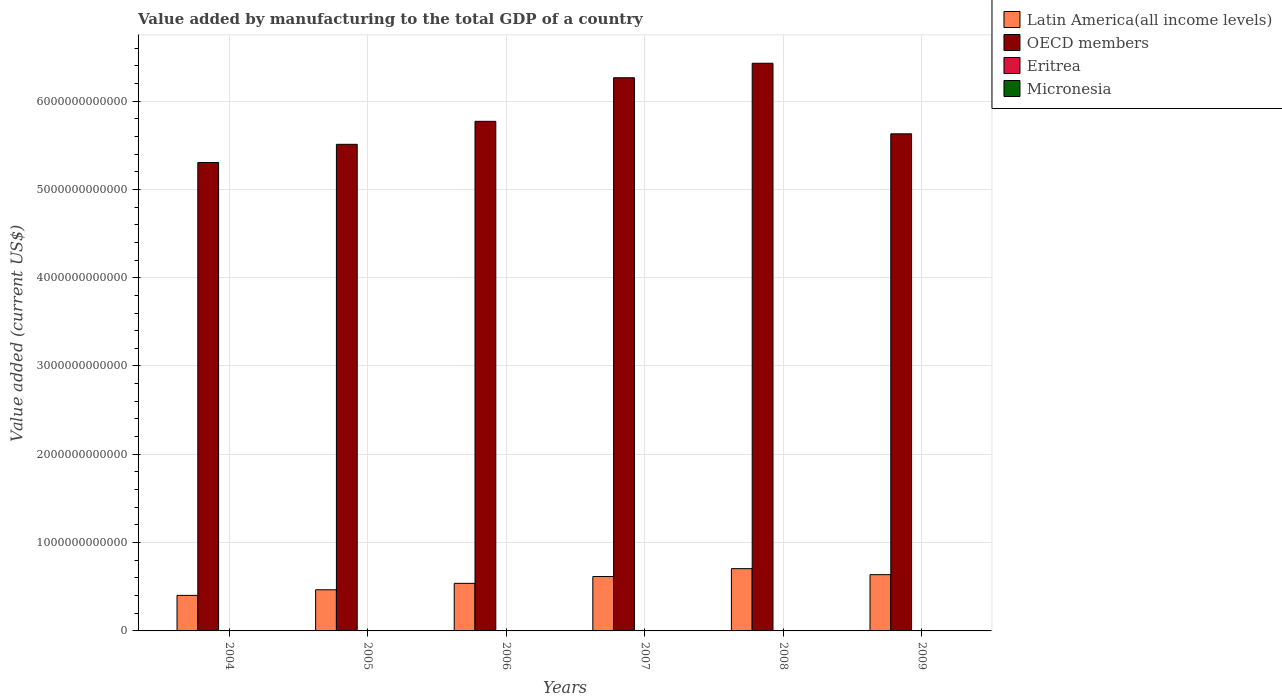Are the number of bars per tick equal to the number of legend labels?
Your response must be concise. Yes. How many bars are there on the 1st tick from the right?
Your answer should be very brief. 4. What is the label of the 6th group of bars from the left?
Offer a very short reply. 2009. What is the value added by manufacturing to the total GDP in Latin America(all income levels) in 2006?
Give a very brief answer. 5.39e+11. Across all years, what is the maximum value added by manufacturing to the total GDP in Eritrea?
Your response must be concise. 1.02e+08. Across all years, what is the minimum value added by manufacturing to the total GDP in Latin America(all income levels)?
Your answer should be very brief. 4.03e+11. In which year was the value added by manufacturing to the total GDP in Latin America(all income levels) maximum?
Keep it short and to the point. 2008. In which year was the value added by manufacturing to the total GDP in OECD members minimum?
Ensure brevity in your answer.  2004. What is the total value added by manufacturing to the total GDP in OECD members in the graph?
Keep it short and to the point. 3.49e+13. What is the difference between the value added by manufacturing to the total GDP in Latin America(all income levels) in 2007 and that in 2008?
Your answer should be compact. -8.91e+1. What is the difference between the value added by manufacturing to the total GDP in OECD members in 2007 and the value added by manufacturing to the total GDP in Eritrea in 2008?
Keep it short and to the point. 6.26e+12. What is the average value added by manufacturing to the total GDP in Eritrea per year?
Provide a succinct answer. 8.44e+07. In the year 2008, what is the difference between the value added by manufacturing to the total GDP in OECD members and value added by manufacturing to the total GDP in Micronesia?
Make the answer very short. 6.43e+12. What is the ratio of the value added by manufacturing to the total GDP in Latin America(all income levels) in 2004 to that in 2005?
Keep it short and to the point. 0.86. Is the difference between the value added by manufacturing to the total GDP in OECD members in 2005 and 2008 greater than the difference between the value added by manufacturing to the total GDP in Micronesia in 2005 and 2008?
Provide a succinct answer. No. What is the difference between the highest and the second highest value added by manufacturing to the total GDP in Eritrea?
Your response must be concise. 6.83e+06. What is the difference between the highest and the lowest value added by manufacturing to the total GDP in Eritrea?
Give a very brief answer. 3.00e+07. In how many years, is the value added by manufacturing to the total GDP in Latin America(all income levels) greater than the average value added by manufacturing to the total GDP in Latin America(all income levels) taken over all years?
Offer a very short reply. 3. Is it the case that in every year, the sum of the value added by manufacturing to the total GDP in OECD members and value added by manufacturing to the total GDP in Micronesia is greater than the sum of value added by manufacturing to the total GDP in Latin America(all income levels) and value added by manufacturing to the total GDP in Eritrea?
Make the answer very short. Yes. What does the 4th bar from the left in 2007 represents?
Keep it short and to the point. Micronesia. What does the 1st bar from the right in 2006 represents?
Your response must be concise. Micronesia. Is it the case that in every year, the sum of the value added by manufacturing to the total GDP in Micronesia and value added by manufacturing to the total GDP in Eritrea is greater than the value added by manufacturing to the total GDP in Latin America(all income levels)?
Your response must be concise. No. How many bars are there?
Give a very brief answer. 24. How many years are there in the graph?
Offer a very short reply. 6. What is the difference between two consecutive major ticks on the Y-axis?
Provide a succinct answer. 1.00e+12. Are the values on the major ticks of Y-axis written in scientific E-notation?
Your answer should be compact. No. Does the graph contain any zero values?
Offer a terse response. No. How many legend labels are there?
Provide a succinct answer. 4. What is the title of the graph?
Offer a very short reply. Value added by manufacturing to the total GDP of a country. Does "Dominica" appear as one of the legend labels in the graph?
Keep it short and to the point. No. What is the label or title of the Y-axis?
Offer a terse response. Value added (current US$). What is the Value added (current US$) in Latin America(all income levels) in 2004?
Offer a very short reply. 4.03e+11. What is the Value added (current US$) of OECD members in 2004?
Offer a very short reply. 5.30e+12. What is the Value added (current US$) in Eritrea in 2004?
Offer a very short reply. 9.52e+07. What is the Value added (current US$) in Micronesia in 2004?
Your answer should be very brief. 3.40e+06. What is the Value added (current US$) in Latin America(all income levels) in 2005?
Offer a very short reply. 4.66e+11. What is the Value added (current US$) in OECD members in 2005?
Your answer should be compact. 5.51e+12. What is the Value added (current US$) in Eritrea in 2005?
Your answer should be very brief. 7.50e+07. What is the Value added (current US$) of Micronesia in 2005?
Your response must be concise. 1.40e+06. What is the Value added (current US$) of Latin America(all income levels) in 2006?
Make the answer very short. 5.39e+11. What is the Value added (current US$) of OECD members in 2006?
Your response must be concise. 5.77e+12. What is the Value added (current US$) in Eritrea in 2006?
Ensure brevity in your answer.  7.25e+07. What is the Value added (current US$) of Micronesia in 2006?
Your response must be concise. 1.00e+06. What is the Value added (current US$) in Latin America(all income levels) in 2007?
Your answer should be very brief. 6.16e+11. What is the Value added (current US$) of OECD members in 2007?
Your response must be concise. 6.26e+12. What is the Value added (current US$) of Eritrea in 2007?
Offer a very short reply. 7.20e+07. What is the Value added (current US$) of Micronesia in 2007?
Ensure brevity in your answer.  1.10e+06. What is the Value added (current US$) of Latin America(all income levels) in 2008?
Provide a short and direct response. 7.05e+11. What is the Value added (current US$) of OECD members in 2008?
Give a very brief answer. 6.43e+12. What is the Value added (current US$) in Eritrea in 2008?
Give a very brief answer. 9.00e+07. What is the Value added (current US$) of Micronesia in 2008?
Ensure brevity in your answer.  1.20e+06. What is the Value added (current US$) of Latin America(all income levels) in 2009?
Ensure brevity in your answer.  6.37e+11. What is the Value added (current US$) in OECD members in 2009?
Provide a succinct answer. 5.63e+12. What is the Value added (current US$) of Eritrea in 2009?
Offer a terse response. 1.02e+08. What is the Value added (current US$) in Micronesia in 2009?
Offer a terse response. 1.20e+06. Across all years, what is the maximum Value added (current US$) in Latin America(all income levels)?
Make the answer very short. 7.05e+11. Across all years, what is the maximum Value added (current US$) in OECD members?
Provide a succinct answer. 6.43e+12. Across all years, what is the maximum Value added (current US$) of Eritrea?
Offer a very short reply. 1.02e+08. Across all years, what is the maximum Value added (current US$) of Micronesia?
Offer a terse response. 3.40e+06. Across all years, what is the minimum Value added (current US$) in Latin America(all income levels)?
Your answer should be compact. 4.03e+11. Across all years, what is the minimum Value added (current US$) of OECD members?
Ensure brevity in your answer.  5.30e+12. Across all years, what is the minimum Value added (current US$) in Eritrea?
Provide a short and direct response. 7.20e+07. What is the total Value added (current US$) in Latin America(all income levels) in the graph?
Your answer should be compact. 3.37e+12. What is the total Value added (current US$) in OECD members in the graph?
Keep it short and to the point. 3.49e+13. What is the total Value added (current US$) of Eritrea in the graph?
Keep it short and to the point. 5.07e+08. What is the total Value added (current US$) of Micronesia in the graph?
Offer a very short reply. 9.30e+06. What is the difference between the Value added (current US$) of Latin America(all income levels) in 2004 and that in 2005?
Give a very brief answer. -6.34e+1. What is the difference between the Value added (current US$) of OECD members in 2004 and that in 2005?
Offer a terse response. -2.06e+11. What is the difference between the Value added (current US$) in Eritrea in 2004 and that in 2005?
Your response must be concise. 2.02e+07. What is the difference between the Value added (current US$) of Micronesia in 2004 and that in 2005?
Your answer should be compact. 2.00e+06. What is the difference between the Value added (current US$) of Latin America(all income levels) in 2004 and that in 2006?
Your answer should be very brief. -1.36e+11. What is the difference between the Value added (current US$) in OECD members in 2004 and that in 2006?
Offer a very short reply. -4.66e+11. What is the difference between the Value added (current US$) in Eritrea in 2004 and that in 2006?
Ensure brevity in your answer.  2.27e+07. What is the difference between the Value added (current US$) of Micronesia in 2004 and that in 2006?
Offer a terse response. 2.40e+06. What is the difference between the Value added (current US$) in Latin America(all income levels) in 2004 and that in 2007?
Offer a terse response. -2.13e+11. What is the difference between the Value added (current US$) of OECD members in 2004 and that in 2007?
Keep it short and to the point. -9.60e+11. What is the difference between the Value added (current US$) of Eritrea in 2004 and that in 2007?
Offer a very short reply. 2.32e+07. What is the difference between the Value added (current US$) of Micronesia in 2004 and that in 2007?
Your answer should be compact. 2.30e+06. What is the difference between the Value added (current US$) of Latin America(all income levels) in 2004 and that in 2008?
Keep it short and to the point. -3.03e+11. What is the difference between the Value added (current US$) in OECD members in 2004 and that in 2008?
Your response must be concise. -1.12e+12. What is the difference between the Value added (current US$) in Eritrea in 2004 and that in 2008?
Your answer should be compact. 5.12e+06. What is the difference between the Value added (current US$) of Micronesia in 2004 and that in 2008?
Provide a short and direct response. 2.20e+06. What is the difference between the Value added (current US$) in Latin America(all income levels) in 2004 and that in 2009?
Provide a short and direct response. -2.35e+11. What is the difference between the Value added (current US$) in OECD members in 2004 and that in 2009?
Provide a short and direct response. -3.25e+11. What is the difference between the Value added (current US$) in Eritrea in 2004 and that in 2009?
Your answer should be compact. -6.83e+06. What is the difference between the Value added (current US$) in Micronesia in 2004 and that in 2009?
Make the answer very short. 2.20e+06. What is the difference between the Value added (current US$) in Latin America(all income levels) in 2005 and that in 2006?
Provide a succinct answer. -7.28e+1. What is the difference between the Value added (current US$) in OECD members in 2005 and that in 2006?
Give a very brief answer. -2.60e+11. What is the difference between the Value added (current US$) of Eritrea in 2005 and that in 2006?
Offer a terse response. 2.52e+06. What is the difference between the Value added (current US$) in Micronesia in 2005 and that in 2006?
Offer a very short reply. 4.00e+05. What is the difference between the Value added (current US$) in Latin America(all income levels) in 2005 and that in 2007?
Provide a short and direct response. -1.50e+11. What is the difference between the Value added (current US$) in OECD members in 2005 and that in 2007?
Ensure brevity in your answer.  -7.54e+11. What is the difference between the Value added (current US$) in Eritrea in 2005 and that in 2007?
Make the answer very short. 3.00e+06. What is the difference between the Value added (current US$) in Micronesia in 2005 and that in 2007?
Provide a short and direct response. 3.00e+05. What is the difference between the Value added (current US$) of Latin America(all income levels) in 2005 and that in 2008?
Your answer should be compact. -2.39e+11. What is the difference between the Value added (current US$) of OECD members in 2005 and that in 2008?
Offer a very short reply. -9.18e+11. What is the difference between the Value added (current US$) in Eritrea in 2005 and that in 2008?
Your response must be concise. -1.50e+07. What is the difference between the Value added (current US$) in Micronesia in 2005 and that in 2008?
Offer a very short reply. 2.00e+05. What is the difference between the Value added (current US$) in Latin America(all income levels) in 2005 and that in 2009?
Keep it short and to the point. -1.71e+11. What is the difference between the Value added (current US$) of OECD members in 2005 and that in 2009?
Your answer should be compact. -1.19e+11. What is the difference between the Value added (current US$) of Eritrea in 2005 and that in 2009?
Ensure brevity in your answer.  -2.70e+07. What is the difference between the Value added (current US$) of Micronesia in 2005 and that in 2009?
Offer a terse response. 2.00e+05. What is the difference between the Value added (current US$) of Latin America(all income levels) in 2006 and that in 2007?
Give a very brief answer. -7.73e+1. What is the difference between the Value added (current US$) of OECD members in 2006 and that in 2007?
Offer a terse response. -4.93e+11. What is the difference between the Value added (current US$) in Eritrea in 2006 and that in 2007?
Ensure brevity in your answer.  4.80e+05. What is the difference between the Value added (current US$) in Micronesia in 2006 and that in 2007?
Provide a succinct answer. -1.00e+05. What is the difference between the Value added (current US$) of Latin America(all income levels) in 2006 and that in 2008?
Provide a succinct answer. -1.66e+11. What is the difference between the Value added (current US$) in OECD members in 2006 and that in 2008?
Ensure brevity in your answer.  -6.58e+11. What is the difference between the Value added (current US$) of Eritrea in 2006 and that in 2008?
Offer a terse response. -1.76e+07. What is the difference between the Value added (current US$) of Latin America(all income levels) in 2006 and that in 2009?
Provide a succinct answer. -9.85e+1. What is the difference between the Value added (current US$) of OECD members in 2006 and that in 2009?
Provide a short and direct response. 1.42e+11. What is the difference between the Value added (current US$) in Eritrea in 2006 and that in 2009?
Offer a very short reply. -2.95e+07. What is the difference between the Value added (current US$) of Micronesia in 2006 and that in 2009?
Your response must be concise. -2.00e+05. What is the difference between the Value added (current US$) in Latin America(all income levels) in 2007 and that in 2008?
Give a very brief answer. -8.91e+1. What is the difference between the Value added (current US$) of OECD members in 2007 and that in 2008?
Provide a succinct answer. -1.64e+11. What is the difference between the Value added (current US$) in Eritrea in 2007 and that in 2008?
Provide a short and direct response. -1.80e+07. What is the difference between the Value added (current US$) of Latin America(all income levels) in 2007 and that in 2009?
Provide a succinct answer. -2.12e+1. What is the difference between the Value added (current US$) of OECD members in 2007 and that in 2009?
Provide a short and direct response. 6.35e+11. What is the difference between the Value added (current US$) of Eritrea in 2007 and that in 2009?
Your answer should be very brief. -3.00e+07. What is the difference between the Value added (current US$) of Latin America(all income levels) in 2008 and that in 2009?
Provide a succinct answer. 6.79e+1. What is the difference between the Value added (current US$) in OECD members in 2008 and that in 2009?
Offer a very short reply. 7.99e+11. What is the difference between the Value added (current US$) in Eritrea in 2008 and that in 2009?
Your answer should be very brief. -1.19e+07. What is the difference between the Value added (current US$) of Micronesia in 2008 and that in 2009?
Make the answer very short. 0. What is the difference between the Value added (current US$) in Latin America(all income levels) in 2004 and the Value added (current US$) in OECD members in 2005?
Make the answer very short. -5.11e+12. What is the difference between the Value added (current US$) of Latin America(all income levels) in 2004 and the Value added (current US$) of Eritrea in 2005?
Provide a short and direct response. 4.02e+11. What is the difference between the Value added (current US$) in Latin America(all income levels) in 2004 and the Value added (current US$) in Micronesia in 2005?
Provide a succinct answer. 4.03e+11. What is the difference between the Value added (current US$) of OECD members in 2004 and the Value added (current US$) of Eritrea in 2005?
Provide a succinct answer. 5.30e+12. What is the difference between the Value added (current US$) in OECD members in 2004 and the Value added (current US$) in Micronesia in 2005?
Your answer should be very brief. 5.30e+12. What is the difference between the Value added (current US$) of Eritrea in 2004 and the Value added (current US$) of Micronesia in 2005?
Offer a very short reply. 9.38e+07. What is the difference between the Value added (current US$) in Latin America(all income levels) in 2004 and the Value added (current US$) in OECD members in 2006?
Give a very brief answer. -5.37e+12. What is the difference between the Value added (current US$) in Latin America(all income levels) in 2004 and the Value added (current US$) in Eritrea in 2006?
Provide a short and direct response. 4.02e+11. What is the difference between the Value added (current US$) of Latin America(all income levels) in 2004 and the Value added (current US$) of Micronesia in 2006?
Your response must be concise. 4.03e+11. What is the difference between the Value added (current US$) of OECD members in 2004 and the Value added (current US$) of Eritrea in 2006?
Provide a succinct answer. 5.30e+12. What is the difference between the Value added (current US$) in OECD members in 2004 and the Value added (current US$) in Micronesia in 2006?
Offer a terse response. 5.30e+12. What is the difference between the Value added (current US$) of Eritrea in 2004 and the Value added (current US$) of Micronesia in 2006?
Give a very brief answer. 9.42e+07. What is the difference between the Value added (current US$) in Latin America(all income levels) in 2004 and the Value added (current US$) in OECD members in 2007?
Your answer should be compact. -5.86e+12. What is the difference between the Value added (current US$) in Latin America(all income levels) in 2004 and the Value added (current US$) in Eritrea in 2007?
Provide a succinct answer. 4.02e+11. What is the difference between the Value added (current US$) in Latin America(all income levels) in 2004 and the Value added (current US$) in Micronesia in 2007?
Ensure brevity in your answer.  4.03e+11. What is the difference between the Value added (current US$) of OECD members in 2004 and the Value added (current US$) of Eritrea in 2007?
Make the answer very short. 5.30e+12. What is the difference between the Value added (current US$) of OECD members in 2004 and the Value added (current US$) of Micronesia in 2007?
Give a very brief answer. 5.30e+12. What is the difference between the Value added (current US$) in Eritrea in 2004 and the Value added (current US$) in Micronesia in 2007?
Make the answer very short. 9.41e+07. What is the difference between the Value added (current US$) of Latin America(all income levels) in 2004 and the Value added (current US$) of OECD members in 2008?
Provide a short and direct response. -6.03e+12. What is the difference between the Value added (current US$) in Latin America(all income levels) in 2004 and the Value added (current US$) in Eritrea in 2008?
Offer a terse response. 4.02e+11. What is the difference between the Value added (current US$) in Latin America(all income levels) in 2004 and the Value added (current US$) in Micronesia in 2008?
Give a very brief answer. 4.03e+11. What is the difference between the Value added (current US$) in OECD members in 2004 and the Value added (current US$) in Eritrea in 2008?
Provide a short and direct response. 5.30e+12. What is the difference between the Value added (current US$) in OECD members in 2004 and the Value added (current US$) in Micronesia in 2008?
Keep it short and to the point. 5.30e+12. What is the difference between the Value added (current US$) in Eritrea in 2004 and the Value added (current US$) in Micronesia in 2008?
Your answer should be compact. 9.40e+07. What is the difference between the Value added (current US$) of Latin America(all income levels) in 2004 and the Value added (current US$) of OECD members in 2009?
Your response must be concise. -5.23e+12. What is the difference between the Value added (current US$) of Latin America(all income levels) in 2004 and the Value added (current US$) of Eritrea in 2009?
Your response must be concise. 4.02e+11. What is the difference between the Value added (current US$) of Latin America(all income levels) in 2004 and the Value added (current US$) of Micronesia in 2009?
Offer a terse response. 4.03e+11. What is the difference between the Value added (current US$) of OECD members in 2004 and the Value added (current US$) of Eritrea in 2009?
Offer a terse response. 5.30e+12. What is the difference between the Value added (current US$) in OECD members in 2004 and the Value added (current US$) in Micronesia in 2009?
Provide a short and direct response. 5.30e+12. What is the difference between the Value added (current US$) of Eritrea in 2004 and the Value added (current US$) of Micronesia in 2009?
Give a very brief answer. 9.40e+07. What is the difference between the Value added (current US$) in Latin America(all income levels) in 2005 and the Value added (current US$) in OECD members in 2006?
Ensure brevity in your answer.  -5.30e+12. What is the difference between the Value added (current US$) of Latin America(all income levels) in 2005 and the Value added (current US$) of Eritrea in 2006?
Offer a very short reply. 4.66e+11. What is the difference between the Value added (current US$) in Latin America(all income levels) in 2005 and the Value added (current US$) in Micronesia in 2006?
Ensure brevity in your answer.  4.66e+11. What is the difference between the Value added (current US$) in OECD members in 2005 and the Value added (current US$) in Eritrea in 2006?
Offer a terse response. 5.51e+12. What is the difference between the Value added (current US$) in OECD members in 2005 and the Value added (current US$) in Micronesia in 2006?
Make the answer very short. 5.51e+12. What is the difference between the Value added (current US$) of Eritrea in 2005 and the Value added (current US$) of Micronesia in 2006?
Give a very brief answer. 7.40e+07. What is the difference between the Value added (current US$) of Latin America(all income levels) in 2005 and the Value added (current US$) of OECD members in 2007?
Provide a short and direct response. -5.80e+12. What is the difference between the Value added (current US$) in Latin America(all income levels) in 2005 and the Value added (current US$) in Eritrea in 2007?
Your answer should be compact. 4.66e+11. What is the difference between the Value added (current US$) in Latin America(all income levels) in 2005 and the Value added (current US$) in Micronesia in 2007?
Provide a succinct answer. 4.66e+11. What is the difference between the Value added (current US$) in OECD members in 2005 and the Value added (current US$) in Eritrea in 2007?
Provide a succinct answer. 5.51e+12. What is the difference between the Value added (current US$) of OECD members in 2005 and the Value added (current US$) of Micronesia in 2007?
Provide a short and direct response. 5.51e+12. What is the difference between the Value added (current US$) of Eritrea in 2005 and the Value added (current US$) of Micronesia in 2007?
Offer a very short reply. 7.39e+07. What is the difference between the Value added (current US$) in Latin America(all income levels) in 2005 and the Value added (current US$) in OECD members in 2008?
Ensure brevity in your answer.  -5.96e+12. What is the difference between the Value added (current US$) in Latin America(all income levels) in 2005 and the Value added (current US$) in Eritrea in 2008?
Give a very brief answer. 4.66e+11. What is the difference between the Value added (current US$) of Latin America(all income levels) in 2005 and the Value added (current US$) of Micronesia in 2008?
Your response must be concise. 4.66e+11. What is the difference between the Value added (current US$) in OECD members in 2005 and the Value added (current US$) in Eritrea in 2008?
Offer a terse response. 5.51e+12. What is the difference between the Value added (current US$) in OECD members in 2005 and the Value added (current US$) in Micronesia in 2008?
Provide a short and direct response. 5.51e+12. What is the difference between the Value added (current US$) in Eritrea in 2005 and the Value added (current US$) in Micronesia in 2008?
Your answer should be very brief. 7.38e+07. What is the difference between the Value added (current US$) of Latin America(all income levels) in 2005 and the Value added (current US$) of OECD members in 2009?
Your answer should be very brief. -5.16e+12. What is the difference between the Value added (current US$) in Latin America(all income levels) in 2005 and the Value added (current US$) in Eritrea in 2009?
Your response must be concise. 4.66e+11. What is the difference between the Value added (current US$) in Latin America(all income levels) in 2005 and the Value added (current US$) in Micronesia in 2009?
Make the answer very short. 4.66e+11. What is the difference between the Value added (current US$) in OECD members in 2005 and the Value added (current US$) in Eritrea in 2009?
Offer a very short reply. 5.51e+12. What is the difference between the Value added (current US$) in OECD members in 2005 and the Value added (current US$) in Micronesia in 2009?
Your response must be concise. 5.51e+12. What is the difference between the Value added (current US$) of Eritrea in 2005 and the Value added (current US$) of Micronesia in 2009?
Offer a very short reply. 7.38e+07. What is the difference between the Value added (current US$) of Latin America(all income levels) in 2006 and the Value added (current US$) of OECD members in 2007?
Your answer should be compact. -5.73e+12. What is the difference between the Value added (current US$) of Latin America(all income levels) in 2006 and the Value added (current US$) of Eritrea in 2007?
Your answer should be very brief. 5.39e+11. What is the difference between the Value added (current US$) of Latin America(all income levels) in 2006 and the Value added (current US$) of Micronesia in 2007?
Make the answer very short. 5.39e+11. What is the difference between the Value added (current US$) of OECD members in 2006 and the Value added (current US$) of Eritrea in 2007?
Offer a terse response. 5.77e+12. What is the difference between the Value added (current US$) of OECD members in 2006 and the Value added (current US$) of Micronesia in 2007?
Your answer should be very brief. 5.77e+12. What is the difference between the Value added (current US$) in Eritrea in 2006 and the Value added (current US$) in Micronesia in 2007?
Your response must be concise. 7.14e+07. What is the difference between the Value added (current US$) in Latin America(all income levels) in 2006 and the Value added (current US$) in OECD members in 2008?
Ensure brevity in your answer.  -5.89e+12. What is the difference between the Value added (current US$) of Latin America(all income levels) in 2006 and the Value added (current US$) of Eritrea in 2008?
Offer a terse response. 5.39e+11. What is the difference between the Value added (current US$) of Latin America(all income levels) in 2006 and the Value added (current US$) of Micronesia in 2008?
Your answer should be compact. 5.39e+11. What is the difference between the Value added (current US$) in OECD members in 2006 and the Value added (current US$) in Eritrea in 2008?
Offer a terse response. 5.77e+12. What is the difference between the Value added (current US$) of OECD members in 2006 and the Value added (current US$) of Micronesia in 2008?
Provide a succinct answer. 5.77e+12. What is the difference between the Value added (current US$) of Eritrea in 2006 and the Value added (current US$) of Micronesia in 2008?
Offer a very short reply. 7.13e+07. What is the difference between the Value added (current US$) in Latin America(all income levels) in 2006 and the Value added (current US$) in OECD members in 2009?
Provide a short and direct response. -5.09e+12. What is the difference between the Value added (current US$) in Latin America(all income levels) in 2006 and the Value added (current US$) in Eritrea in 2009?
Your answer should be very brief. 5.39e+11. What is the difference between the Value added (current US$) in Latin America(all income levels) in 2006 and the Value added (current US$) in Micronesia in 2009?
Keep it short and to the point. 5.39e+11. What is the difference between the Value added (current US$) in OECD members in 2006 and the Value added (current US$) in Eritrea in 2009?
Your answer should be very brief. 5.77e+12. What is the difference between the Value added (current US$) of OECD members in 2006 and the Value added (current US$) of Micronesia in 2009?
Your answer should be compact. 5.77e+12. What is the difference between the Value added (current US$) in Eritrea in 2006 and the Value added (current US$) in Micronesia in 2009?
Your response must be concise. 7.13e+07. What is the difference between the Value added (current US$) of Latin America(all income levels) in 2007 and the Value added (current US$) of OECD members in 2008?
Provide a short and direct response. -5.81e+12. What is the difference between the Value added (current US$) in Latin America(all income levels) in 2007 and the Value added (current US$) in Eritrea in 2008?
Make the answer very short. 6.16e+11. What is the difference between the Value added (current US$) in Latin America(all income levels) in 2007 and the Value added (current US$) in Micronesia in 2008?
Your answer should be compact. 6.16e+11. What is the difference between the Value added (current US$) in OECD members in 2007 and the Value added (current US$) in Eritrea in 2008?
Give a very brief answer. 6.26e+12. What is the difference between the Value added (current US$) in OECD members in 2007 and the Value added (current US$) in Micronesia in 2008?
Give a very brief answer. 6.26e+12. What is the difference between the Value added (current US$) of Eritrea in 2007 and the Value added (current US$) of Micronesia in 2008?
Make the answer very short. 7.08e+07. What is the difference between the Value added (current US$) in Latin America(all income levels) in 2007 and the Value added (current US$) in OECD members in 2009?
Offer a terse response. -5.01e+12. What is the difference between the Value added (current US$) in Latin America(all income levels) in 2007 and the Value added (current US$) in Eritrea in 2009?
Offer a terse response. 6.16e+11. What is the difference between the Value added (current US$) in Latin America(all income levels) in 2007 and the Value added (current US$) in Micronesia in 2009?
Keep it short and to the point. 6.16e+11. What is the difference between the Value added (current US$) of OECD members in 2007 and the Value added (current US$) of Eritrea in 2009?
Give a very brief answer. 6.26e+12. What is the difference between the Value added (current US$) of OECD members in 2007 and the Value added (current US$) of Micronesia in 2009?
Offer a very short reply. 6.26e+12. What is the difference between the Value added (current US$) of Eritrea in 2007 and the Value added (current US$) of Micronesia in 2009?
Keep it short and to the point. 7.08e+07. What is the difference between the Value added (current US$) of Latin America(all income levels) in 2008 and the Value added (current US$) of OECD members in 2009?
Your answer should be very brief. -4.92e+12. What is the difference between the Value added (current US$) in Latin America(all income levels) in 2008 and the Value added (current US$) in Eritrea in 2009?
Offer a very short reply. 7.05e+11. What is the difference between the Value added (current US$) in Latin America(all income levels) in 2008 and the Value added (current US$) in Micronesia in 2009?
Make the answer very short. 7.05e+11. What is the difference between the Value added (current US$) in OECD members in 2008 and the Value added (current US$) in Eritrea in 2009?
Make the answer very short. 6.43e+12. What is the difference between the Value added (current US$) of OECD members in 2008 and the Value added (current US$) of Micronesia in 2009?
Ensure brevity in your answer.  6.43e+12. What is the difference between the Value added (current US$) in Eritrea in 2008 and the Value added (current US$) in Micronesia in 2009?
Provide a succinct answer. 8.88e+07. What is the average Value added (current US$) in Latin America(all income levels) per year?
Give a very brief answer. 5.61e+11. What is the average Value added (current US$) in OECD members per year?
Make the answer very short. 5.82e+12. What is the average Value added (current US$) of Eritrea per year?
Your response must be concise. 8.44e+07. What is the average Value added (current US$) in Micronesia per year?
Offer a terse response. 1.55e+06. In the year 2004, what is the difference between the Value added (current US$) in Latin America(all income levels) and Value added (current US$) in OECD members?
Offer a very short reply. -4.90e+12. In the year 2004, what is the difference between the Value added (current US$) in Latin America(all income levels) and Value added (current US$) in Eritrea?
Ensure brevity in your answer.  4.02e+11. In the year 2004, what is the difference between the Value added (current US$) of Latin America(all income levels) and Value added (current US$) of Micronesia?
Provide a succinct answer. 4.03e+11. In the year 2004, what is the difference between the Value added (current US$) of OECD members and Value added (current US$) of Eritrea?
Make the answer very short. 5.30e+12. In the year 2004, what is the difference between the Value added (current US$) of OECD members and Value added (current US$) of Micronesia?
Your answer should be very brief. 5.30e+12. In the year 2004, what is the difference between the Value added (current US$) in Eritrea and Value added (current US$) in Micronesia?
Ensure brevity in your answer.  9.18e+07. In the year 2005, what is the difference between the Value added (current US$) of Latin America(all income levels) and Value added (current US$) of OECD members?
Your answer should be very brief. -5.04e+12. In the year 2005, what is the difference between the Value added (current US$) of Latin America(all income levels) and Value added (current US$) of Eritrea?
Provide a succinct answer. 4.66e+11. In the year 2005, what is the difference between the Value added (current US$) in Latin America(all income levels) and Value added (current US$) in Micronesia?
Ensure brevity in your answer.  4.66e+11. In the year 2005, what is the difference between the Value added (current US$) in OECD members and Value added (current US$) in Eritrea?
Provide a succinct answer. 5.51e+12. In the year 2005, what is the difference between the Value added (current US$) in OECD members and Value added (current US$) in Micronesia?
Your answer should be compact. 5.51e+12. In the year 2005, what is the difference between the Value added (current US$) of Eritrea and Value added (current US$) of Micronesia?
Your answer should be compact. 7.36e+07. In the year 2006, what is the difference between the Value added (current US$) of Latin America(all income levels) and Value added (current US$) of OECD members?
Offer a terse response. -5.23e+12. In the year 2006, what is the difference between the Value added (current US$) in Latin America(all income levels) and Value added (current US$) in Eritrea?
Your response must be concise. 5.39e+11. In the year 2006, what is the difference between the Value added (current US$) in Latin America(all income levels) and Value added (current US$) in Micronesia?
Your answer should be compact. 5.39e+11. In the year 2006, what is the difference between the Value added (current US$) in OECD members and Value added (current US$) in Eritrea?
Offer a very short reply. 5.77e+12. In the year 2006, what is the difference between the Value added (current US$) of OECD members and Value added (current US$) of Micronesia?
Keep it short and to the point. 5.77e+12. In the year 2006, what is the difference between the Value added (current US$) of Eritrea and Value added (current US$) of Micronesia?
Provide a short and direct response. 7.15e+07. In the year 2007, what is the difference between the Value added (current US$) of Latin America(all income levels) and Value added (current US$) of OECD members?
Your answer should be very brief. -5.65e+12. In the year 2007, what is the difference between the Value added (current US$) of Latin America(all income levels) and Value added (current US$) of Eritrea?
Give a very brief answer. 6.16e+11. In the year 2007, what is the difference between the Value added (current US$) in Latin America(all income levels) and Value added (current US$) in Micronesia?
Your answer should be compact. 6.16e+11. In the year 2007, what is the difference between the Value added (current US$) of OECD members and Value added (current US$) of Eritrea?
Your answer should be very brief. 6.26e+12. In the year 2007, what is the difference between the Value added (current US$) in OECD members and Value added (current US$) in Micronesia?
Give a very brief answer. 6.26e+12. In the year 2007, what is the difference between the Value added (current US$) of Eritrea and Value added (current US$) of Micronesia?
Ensure brevity in your answer.  7.09e+07. In the year 2008, what is the difference between the Value added (current US$) in Latin America(all income levels) and Value added (current US$) in OECD members?
Provide a succinct answer. -5.72e+12. In the year 2008, what is the difference between the Value added (current US$) of Latin America(all income levels) and Value added (current US$) of Eritrea?
Provide a short and direct response. 7.05e+11. In the year 2008, what is the difference between the Value added (current US$) in Latin America(all income levels) and Value added (current US$) in Micronesia?
Offer a very short reply. 7.05e+11. In the year 2008, what is the difference between the Value added (current US$) of OECD members and Value added (current US$) of Eritrea?
Your answer should be very brief. 6.43e+12. In the year 2008, what is the difference between the Value added (current US$) in OECD members and Value added (current US$) in Micronesia?
Keep it short and to the point. 6.43e+12. In the year 2008, what is the difference between the Value added (current US$) in Eritrea and Value added (current US$) in Micronesia?
Provide a short and direct response. 8.88e+07. In the year 2009, what is the difference between the Value added (current US$) of Latin America(all income levels) and Value added (current US$) of OECD members?
Keep it short and to the point. -4.99e+12. In the year 2009, what is the difference between the Value added (current US$) of Latin America(all income levels) and Value added (current US$) of Eritrea?
Give a very brief answer. 6.37e+11. In the year 2009, what is the difference between the Value added (current US$) of Latin America(all income levels) and Value added (current US$) of Micronesia?
Give a very brief answer. 6.37e+11. In the year 2009, what is the difference between the Value added (current US$) of OECD members and Value added (current US$) of Eritrea?
Your response must be concise. 5.63e+12. In the year 2009, what is the difference between the Value added (current US$) of OECD members and Value added (current US$) of Micronesia?
Your response must be concise. 5.63e+12. In the year 2009, what is the difference between the Value added (current US$) of Eritrea and Value added (current US$) of Micronesia?
Provide a short and direct response. 1.01e+08. What is the ratio of the Value added (current US$) in Latin America(all income levels) in 2004 to that in 2005?
Make the answer very short. 0.86. What is the ratio of the Value added (current US$) of OECD members in 2004 to that in 2005?
Your answer should be compact. 0.96. What is the ratio of the Value added (current US$) in Eritrea in 2004 to that in 2005?
Provide a succinct answer. 1.27. What is the ratio of the Value added (current US$) of Micronesia in 2004 to that in 2005?
Your answer should be very brief. 2.43. What is the ratio of the Value added (current US$) in Latin America(all income levels) in 2004 to that in 2006?
Provide a succinct answer. 0.75. What is the ratio of the Value added (current US$) in OECD members in 2004 to that in 2006?
Keep it short and to the point. 0.92. What is the ratio of the Value added (current US$) of Eritrea in 2004 to that in 2006?
Keep it short and to the point. 1.31. What is the ratio of the Value added (current US$) in Micronesia in 2004 to that in 2006?
Your answer should be very brief. 3.4. What is the ratio of the Value added (current US$) in Latin America(all income levels) in 2004 to that in 2007?
Provide a succinct answer. 0.65. What is the ratio of the Value added (current US$) of OECD members in 2004 to that in 2007?
Keep it short and to the point. 0.85. What is the ratio of the Value added (current US$) in Eritrea in 2004 to that in 2007?
Make the answer very short. 1.32. What is the ratio of the Value added (current US$) in Micronesia in 2004 to that in 2007?
Your answer should be compact. 3.09. What is the ratio of the Value added (current US$) in Latin America(all income levels) in 2004 to that in 2008?
Give a very brief answer. 0.57. What is the ratio of the Value added (current US$) in OECD members in 2004 to that in 2008?
Provide a succinct answer. 0.83. What is the ratio of the Value added (current US$) in Eritrea in 2004 to that in 2008?
Provide a short and direct response. 1.06. What is the ratio of the Value added (current US$) in Micronesia in 2004 to that in 2008?
Your answer should be compact. 2.83. What is the ratio of the Value added (current US$) of Latin America(all income levels) in 2004 to that in 2009?
Offer a very short reply. 0.63. What is the ratio of the Value added (current US$) of OECD members in 2004 to that in 2009?
Give a very brief answer. 0.94. What is the ratio of the Value added (current US$) of Eritrea in 2004 to that in 2009?
Ensure brevity in your answer.  0.93. What is the ratio of the Value added (current US$) of Micronesia in 2004 to that in 2009?
Provide a short and direct response. 2.83. What is the ratio of the Value added (current US$) of Latin America(all income levels) in 2005 to that in 2006?
Your answer should be very brief. 0.86. What is the ratio of the Value added (current US$) in OECD members in 2005 to that in 2006?
Give a very brief answer. 0.95. What is the ratio of the Value added (current US$) in Eritrea in 2005 to that in 2006?
Give a very brief answer. 1.03. What is the ratio of the Value added (current US$) of Latin America(all income levels) in 2005 to that in 2007?
Keep it short and to the point. 0.76. What is the ratio of the Value added (current US$) in OECD members in 2005 to that in 2007?
Your answer should be very brief. 0.88. What is the ratio of the Value added (current US$) of Eritrea in 2005 to that in 2007?
Provide a short and direct response. 1.04. What is the ratio of the Value added (current US$) in Micronesia in 2005 to that in 2007?
Make the answer very short. 1.27. What is the ratio of the Value added (current US$) of Latin America(all income levels) in 2005 to that in 2008?
Keep it short and to the point. 0.66. What is the ratio of the Value added (current US$) of OECD members in 2005 to that in 2008?
Provide a succinct answer. 0.86. What is the ratio of the Value added (current US$) of Eritrea in 2005 to that in 2008?
Your answer should be compact. 0.83. What is the ratio of the Value added (current US$) in Latin America(all income levels) in 2005 to that in 2009?
Ensure brevity in your answer.  0.73. What is the ratio of the Value added (current US$) of OECD members in 2005 to that in 2009?
Your response must be concise. 0.98. What is the ratio of the Value added (current US$) of Eritrea in 2005 to that in 2009?
Your answer should be very brief. 0.74. What is the ratio of the Value added (current US$) in Latin America(all income levels) in 2006 to that in 2007?
Offer a very short reply. 0.87. What is the ratio of the Value added (current US$) of OECD members in 2006 to that in 2007?
Make the answer very short. 0.92. What is the ratio of the Value added (current US$) of Eritrea in 2006 to that in 2007?
Offer a very short reply. 1.01. What is the ratio of the Value added (current US$) in Latin America(all income levels) in 2006 to that in 2008?
Provide a succinct answer. 0.76. What is the ratio of the Value added (current US$) of OECD members in 2006 to that in 2008?
Provide a succinct answer. 0.9. What is the ratio of the Value added (current US$) of Eritrea in 2006 to that in 2008?
Make the answer very short. 0.81. What is the ratio of the Value added (current US$) in Latin America(all income levels) in 2006 to that in 2009?
Your answer should be very brief. 0.85. What is the ratio of the Value added (current US$) in OECD members in 2006 to that in 2009?
Offer a terse response. 1.03. What is the ratio of the Value added (current US$) in Eritrea in 2006 to that in 2009?
Your answer should be compact. 0.71. What is the ratio of the Value added (current US$) in Micronesia in 2006 to that in 2009?
Your response must be concise. 0.83. What is the ratio of the Value added (current US$) of Latin America(all income levels) in 2007 to that in 2008?
Your answer should be very brief. 0.87. What is the ratio of the Value added (current US$) of OECD members in 2007 to that in 2008?
Ensure brevity in your answer.  0.97. What is the ratio of the Value added (current US$) in Eritrea in 2007 to that in 2008?
Give a very brief answer. 0.8. What is the ratio of the Value added (current US$) in Micronesia in 2007 to that in 2008?
Ensure brevity in your answer.  0.92. What is the ratio of the Value added (current US$) in Latin America(all income levels) in 2007 to that in 2009?
Offer a terse response. 0.97. What is the ratio of the Value added (current US$) of OECD members in 2007 to that in 2009?
Make the answer very short. 1.11. What is the ratio of the Value added (current US$) in Eritrea in 2007 to that in 2009?
Make the answer very short. 0.71. What is the ratio of the Value added (current US$) of Latin America(all income levels) in 2008 to that in 2009?
Offer a very short reply. 1.11. What is the ratio of the Value added (current US$) of OECD members in 2008 to that in 2009?
Offer a very short reply. 1.14. What is the ratio of the Value added (current US$) in Eritrea in 2008 to that in 2009?
Offer a terse response. 0.88. What is the ratio of the Value added (current US$) in Micronesia in 2008 to that in 2009?
Keep it short and to the point. 1. What is the difference between the highest and the second highest Value added (current US$) in Latin America(all income levels)?
Your response must be concise. 6.79e+1. What is the difference between the highest and the second highest Value added (current US$) in OECD members?
Your answer should be compact. 1.64e+11. What is the difference between the highest and the second highest Value added (current US$) in Eritrea?
Provide a succinct answer. 6.83e+06. What is the difference between the highest and the lowest Value added (current US$) in Latin America(all income levels)?
Provide a short and direct response. 3.03e+11. What is the difference between the highest and the lowest Value added (current US$) in OECD members?
Your response must be concise. 1.12e+12. What is the difference between the highest and the lowest Value added (current US$) in Eritrea?
Provide a succinct answer. 3.00e+07. What is the difference between the highest and the lowest Value added (current US$) of Micronesia?
Provide a succinct answer. 2.40e+06. 